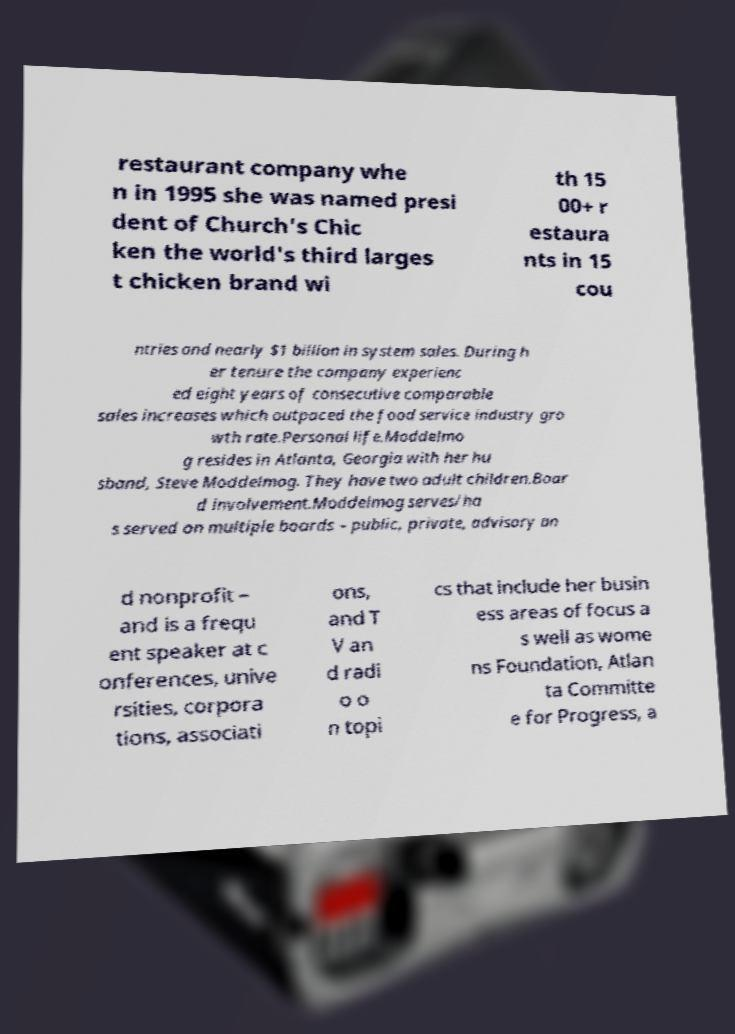Could you extract and type out the text from this image? restaurant company whe n in 1995 she was named presi dent of Church's Chic ken the world's third larges t chicken brand wi th 15 00+ r estaura nts in 15 cou ntries and nearly $1 billion in system sales. During h er tenure the company experienc ed eight years of consecutive comparable sales increases which outpaced the food service industry gro wth rate.Personal life.Moddelmo g resides in Atlanta, Georgia with her hu sband, Steve Moddelmog. They have two adult children.Boar d involvement.Moddelmog serves/ha s served on multiple boards – public, private, advisory an d nonprofit – and is a frequ ent speaker at c onferences, unive rsities, corpora tions, associati ons, and T V an d radi o o n topi cs that include her busin ess areas of focus a s well as wome ns Foundation, Atlan ta Committe e for Progress, a 